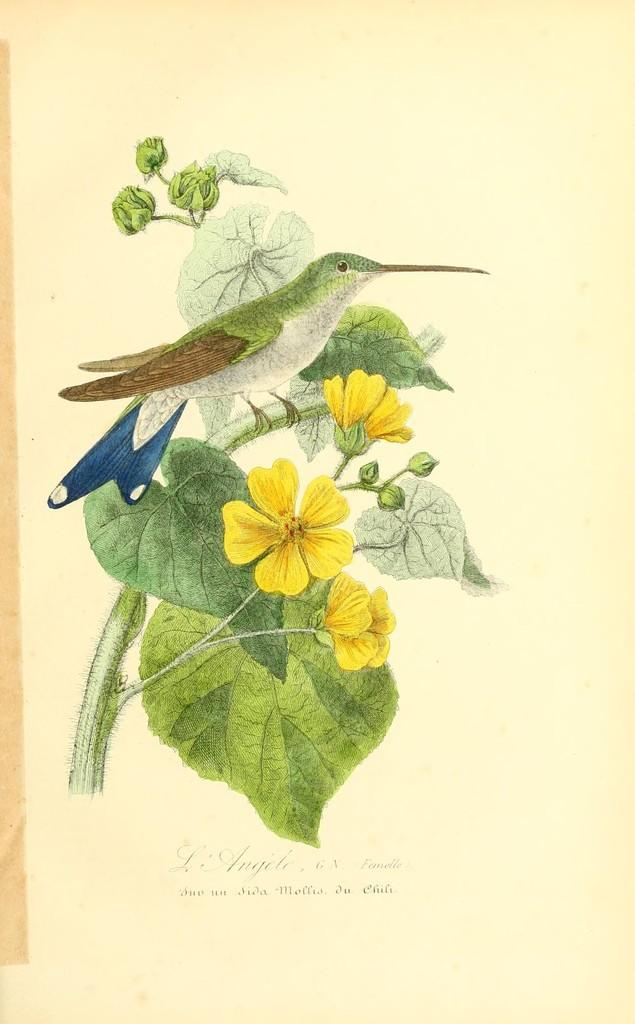What is depicted in the art of the image? There is an art of a bird in the image. Where is the bird located in the image? The bird is on a plant stem in the image. What type of flowers can be seen in the image? There are yellow color flowers in the image. What stage of growth are the plants in the image? There are buds of a plant in the image. Is there any text in the image? Yes, there is edited text at the bottom of the image. What story does the servant tell about the bird in the image? There is no servant or story present in the image; it only features an art of a bird, flowers, and plant buds. 